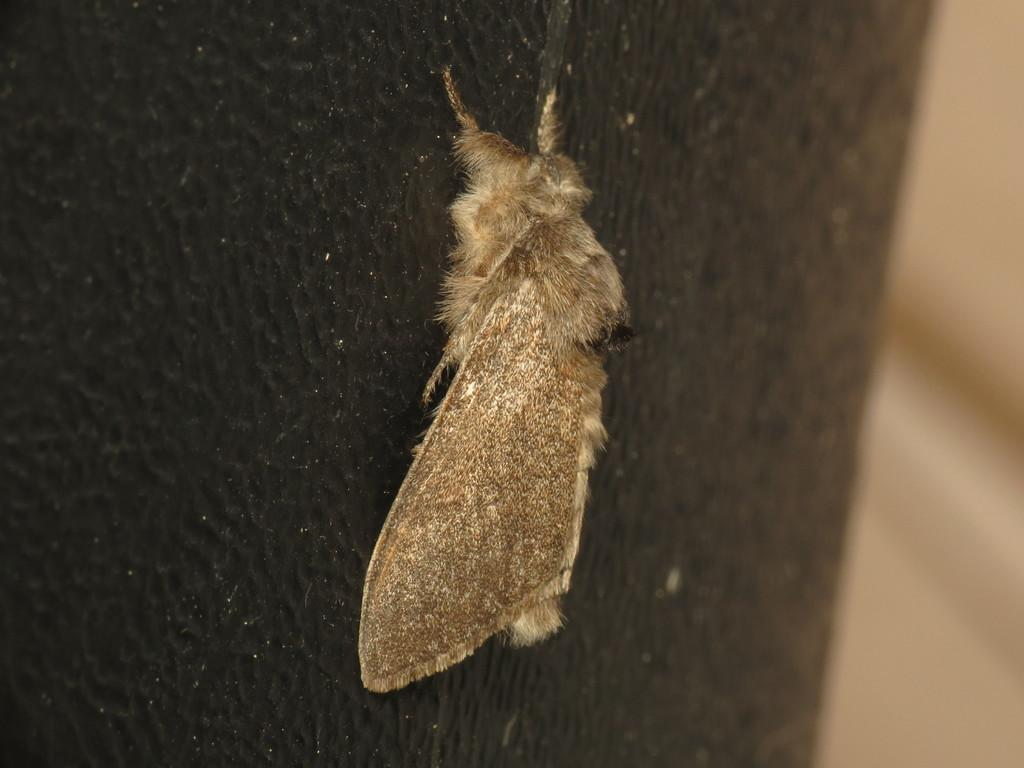What type of insect is in the image? There is a moth in the image. What is the moth resting on? The moth is on a black object. Can you describe the background of the image? The background of the image is blurry. What type of basket is the moth using for pleasure in the image? There is no basket or pleasure-related activity involving the moth in the image. 